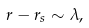Convert formula to latex. <formula><loc_0><loc_0><loc_500><loc_500>r - r _ { s } \sim \lambda ,</formula> 